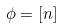Convert formula to latex. <formula><loc_0><loc_0><loc_500><loc_500>\phi = [ n ]</formula> 